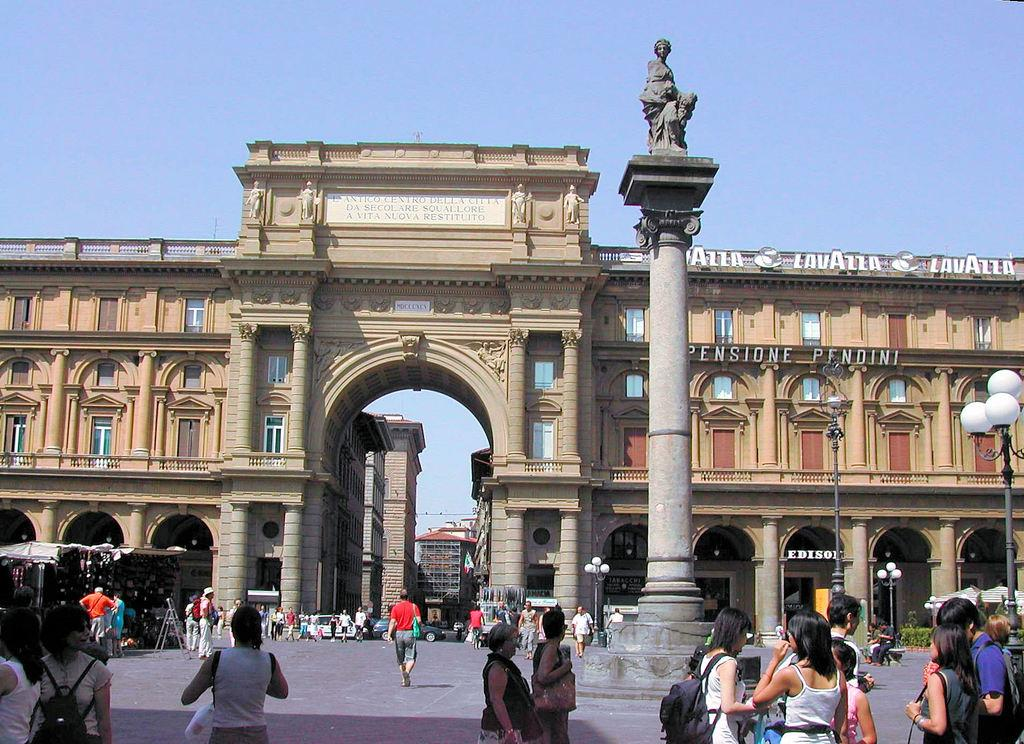What are the people in the image doing? The people in the image are walking on the streets. What can be seen in the background of the image? There are buildings visible in the background of the image. What type of boot is being used to control the pest in the image? There is no boot or pest present in the image; it features people walking on the streets and buildings in the background. 